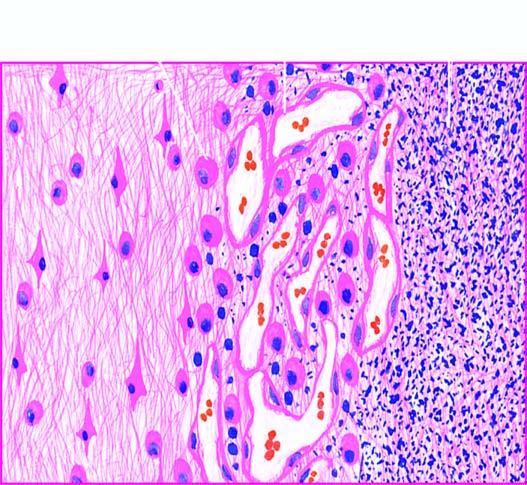what does the necrosed area on right side of the field show?
Answer the question using a single word or phrase. Cystic space containing cell debris 